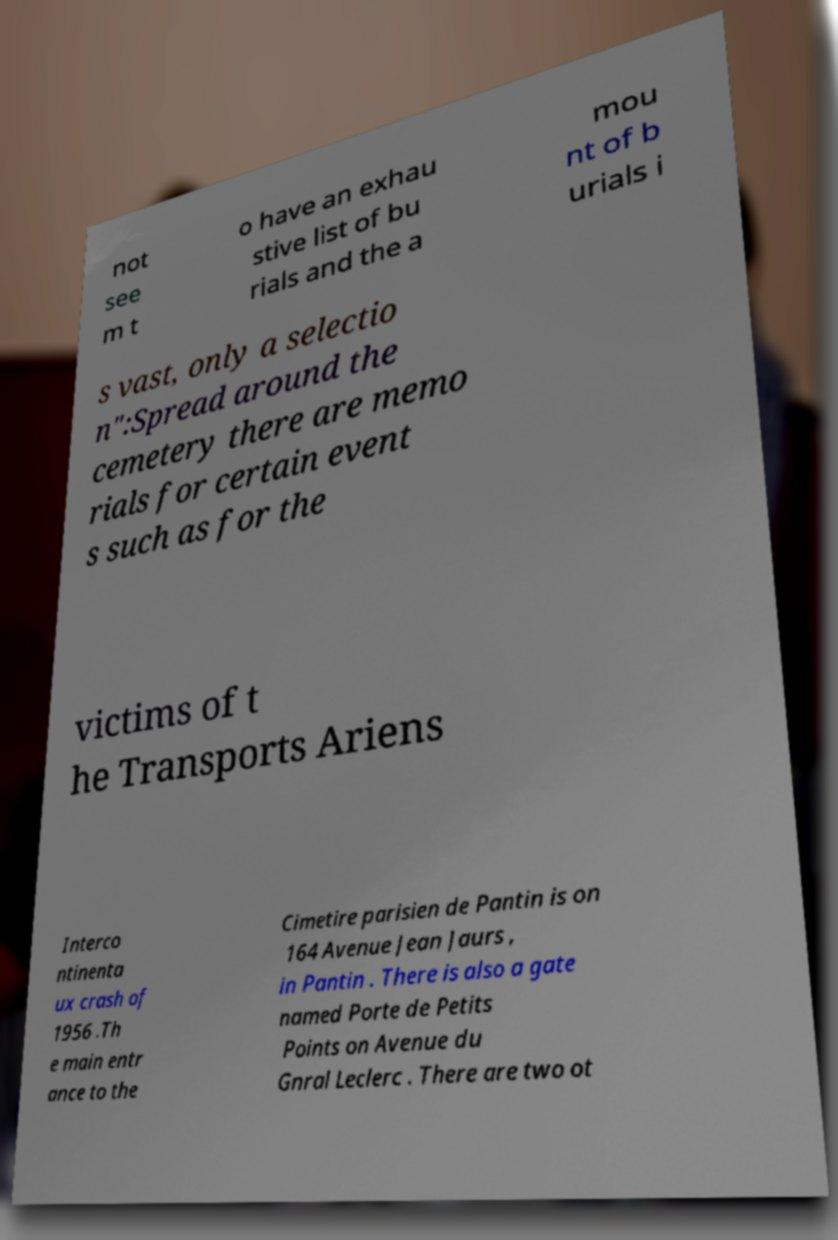I need the written content from this picture converted into text. Can you do that? not see m t o have an exhau stive list of bu rials and the a mou nt of b urials i s vast, only a selectio n":Spread around the cemetery there are memo rials for certain event s such as for the victims of t he Transports Ariens Interco ntinenta ux crash of 1956 .Th e main entr ance to the Cimetire parisien de Pantin is on 164 Avenue Jean Jaurs , in Pantin . There is also a gate named Porte de Petits Points on Avenue du Gnral Leclerc . There are two ot 